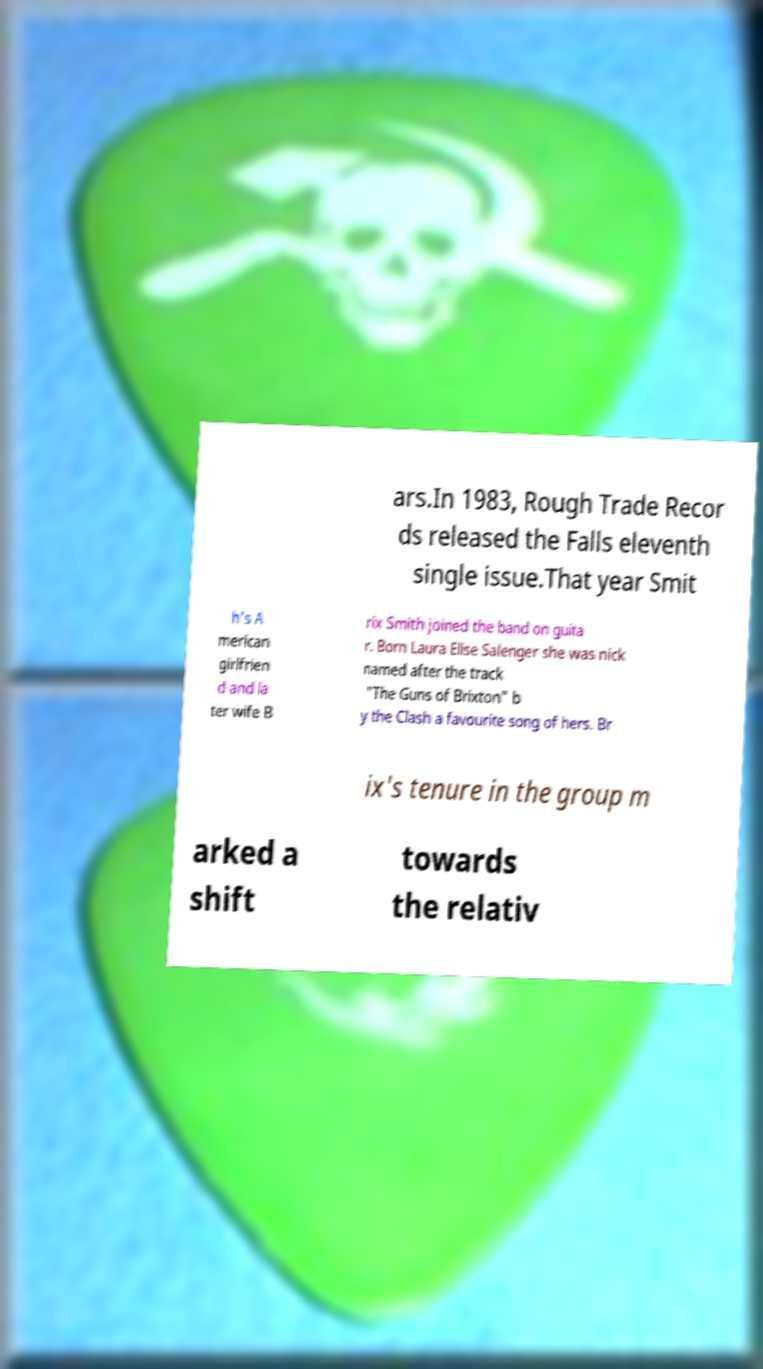There's text embedded in this image that I need extracted. Can you transcribe it verbatim? ars.In 1983, Rough Trade Recor ds released the Falls eleventh single issue.That year Smit h's A merican girlfrien d and la ter wife B rix Smith joined the band on guita r. Born Laura Elise Salenger she was nick named after the track "The Guns of Brixton" b y the Clash a favourite song of hers. Br ix's tenure in the group m arked a shift towards the relativ 